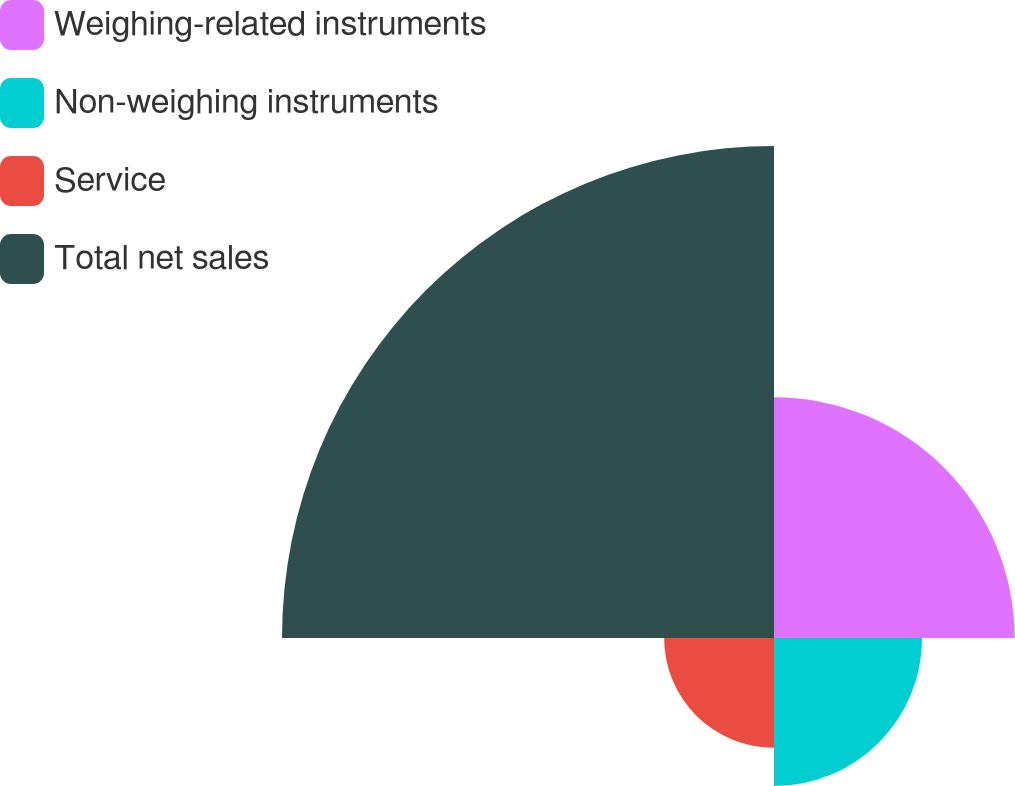<chart> <loc_0><loc_0><loc_500><loc_500><pie_chart><fcel>Weighing-related instruments<fcel>Non-weighing instruments<fcel>Service<fcel>Total net sales<nl><fcel>24.3%<fcel>14.95%<fcel>11.09%<fcel>49.67%<nl></chart> 